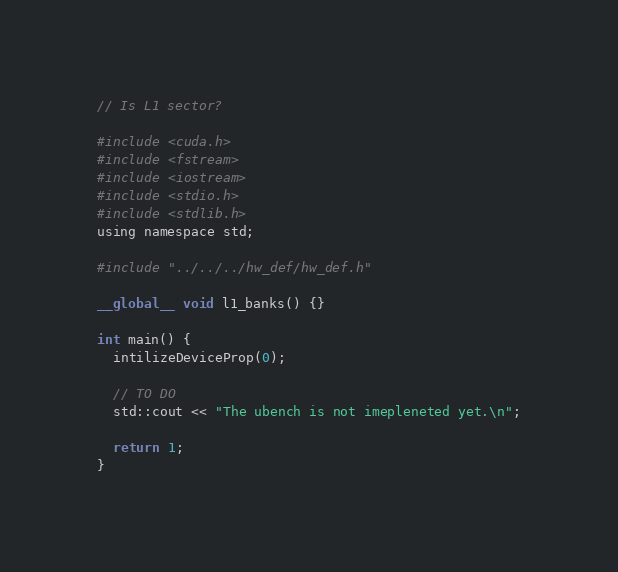<code> <loc_0><loc_0><loc_500><loc_500><_Cuda_>// Is L1 sector?

#include <cuda.h>
#include <fstream>
#include <iostream>
#include <stdio.h>
#include <stdlib.h>
using namespace std;

#include "../../../hw_def/hw_def.h"

__global__ void l1_banks() {}

int main() {
  intilizeDeviceProp(0);

  // TO DO
  std::cout << "The ubench is not imepleneted yet.\n";

  return 1;
}
</code> 